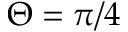Convert formula to latex. <formula><loc_0><loc_0><loc_500><loc_500>\Theta = \pi / 4</formula> 